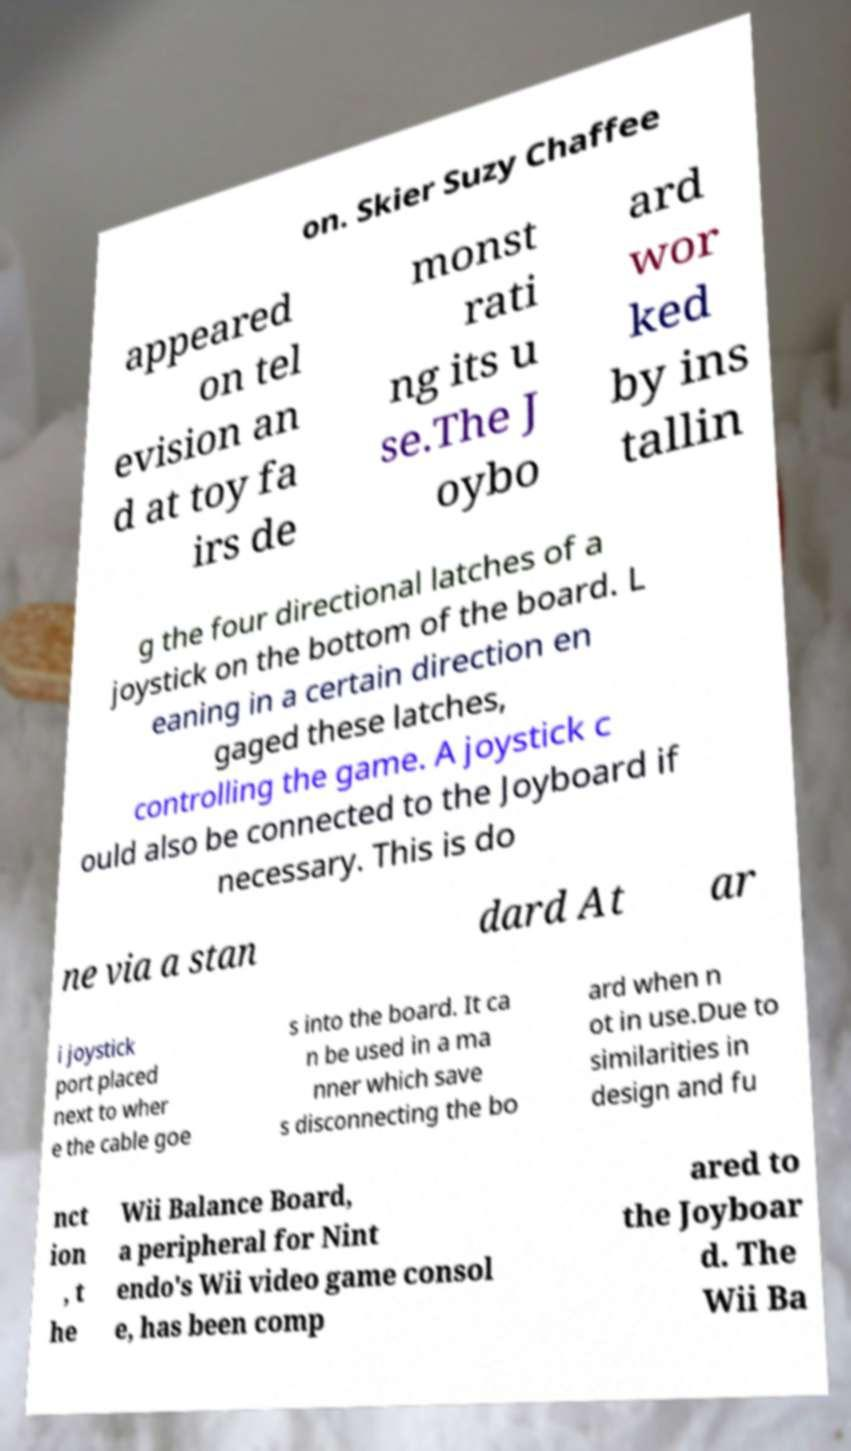Can you read and provide the text displayed in the image?This photo seems to have some interesting text. Can you extract and type it out for me? on. Skier Suzy Chaffee appeared on tel evision an d at toy fa irs de monst rati ng its u se.The J oybo ard wor ked by ins tallin g the four directional latches of a joystick on the bottom of the board. L eaning in a certain direction en gaged these latches, controlling the game. A joystick c ould also be connected to the Joyboard if necessary. This is do ne via a stan dard At ar i joystick port placed next to wher e the cable goe s into the board. It ca n be used in a ma nner which save s disconnecting the bo ard when n ot in use.Due to similarities in design and fu nct ion , t he Wii Balance Board, a peripheral for Nint endo's Wii video game consol e, has been comp ared to the Joyboar d. The Wii Ba 